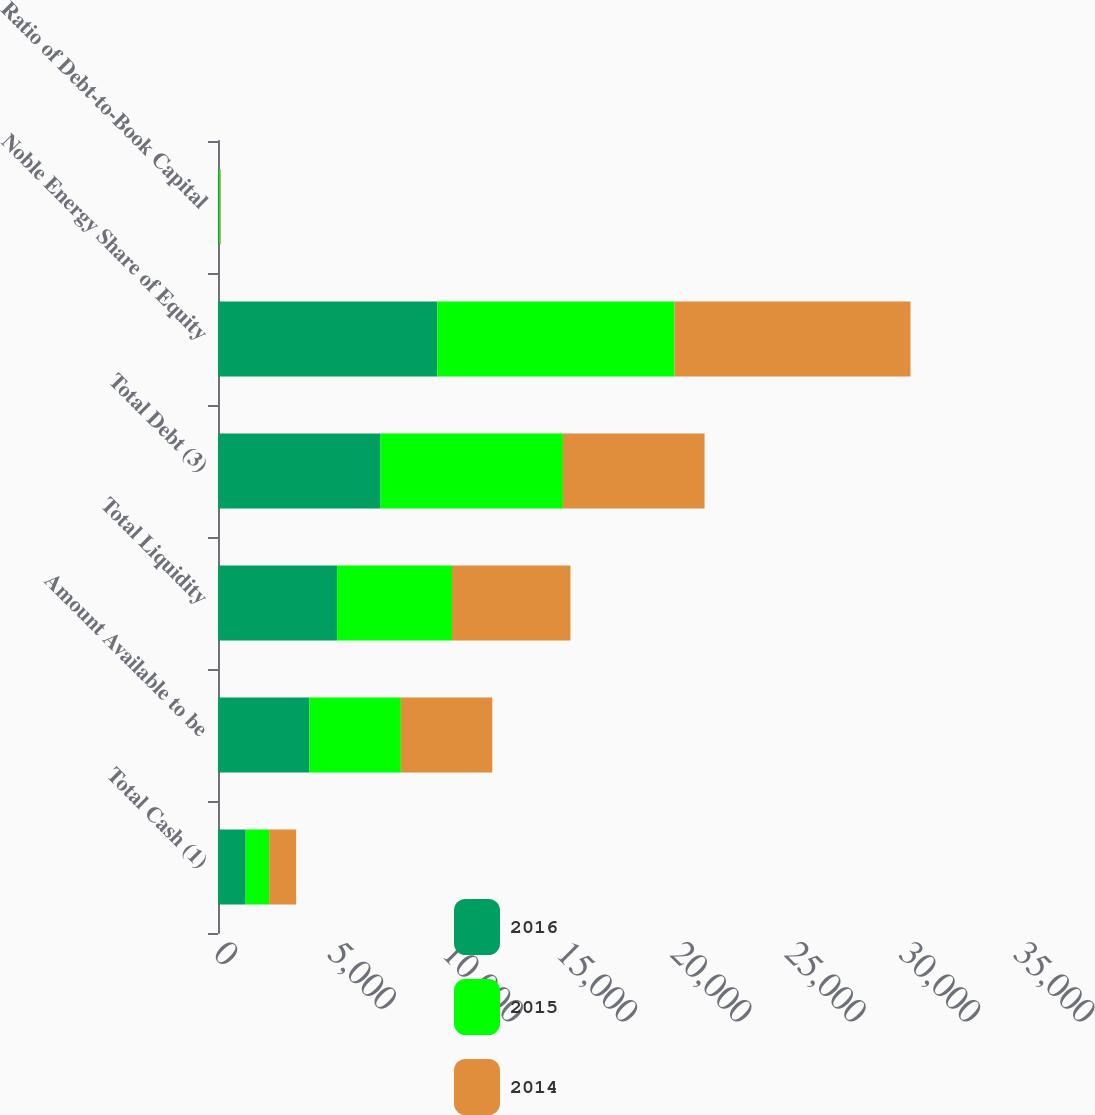<chart> <loc_0><loc_0><loc_500><loc_500><stacked_bar_chart><ecel><fcel>Total Cash (1)<fcel>Amount Available to be<fcel>Total Liquidity<fcel>Total Debt (3)<fcel>Noble Energy Share of Equity<fcel>Ratio of Debt-to-Book Capital<nl><fcel>2016<fcel>1209<fcel>4000<fcel>5209<fcel>7114<fcel>9600<fcel>43<nl><fcel>2015<fcel>1028<fcel>4000<fcel>5028<fcel>7976<fcel>10370<fcel>43<nl><fcel>2014<fcel>1183<fcel>4000<fcel>5183<fcel>6197<fcel>10325<fcel>38<nl></chart> 